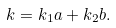<formula> <loc_0><loc_0><loc_500><loc_500>k = k _ { 1 } a + k _ { 2 } b .</formula> 